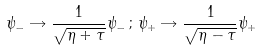<formula> <loc_0><loc_0><loc_500><loc_500>\psi _ { - } \rightarrow \frac { 1 } { \sqrt { \eta + \tau } } \psi _ { - } \, ; \, \psi _ { + } \rightarrow \frac { 1 } { \sqrt { \eta - \tau } } \psi _ { + }</formula> 